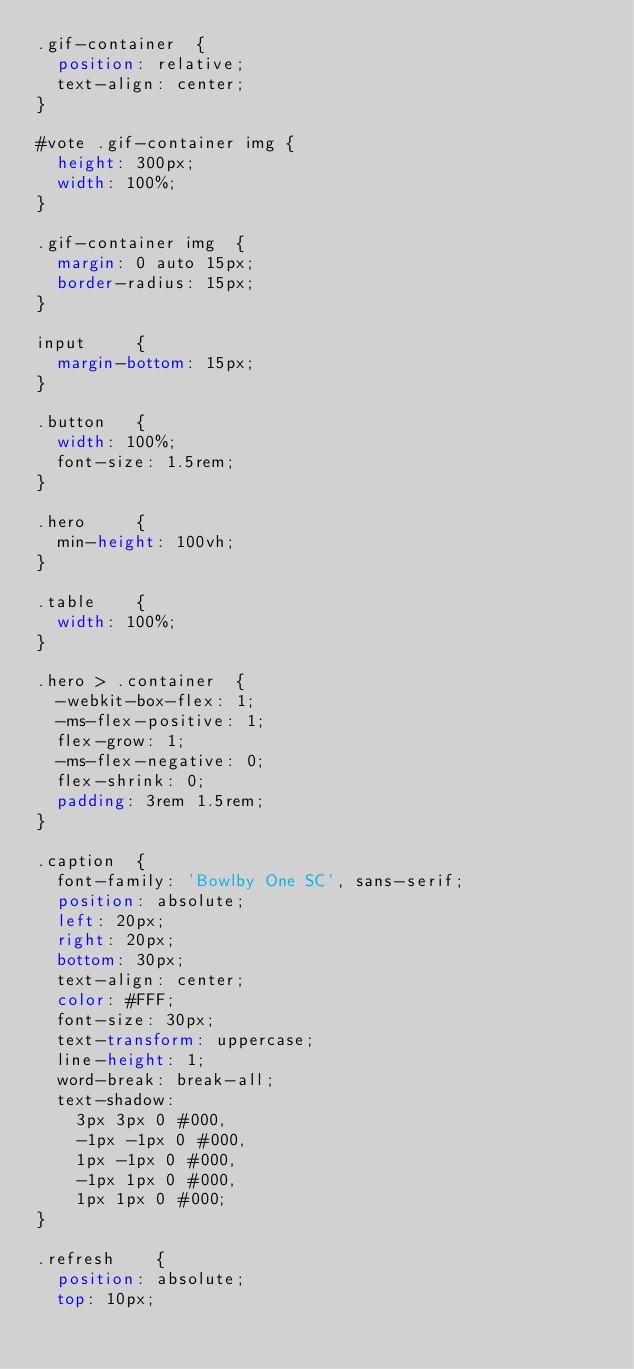Convert code to text. <code><loc_0><loc_0><loc_500><loc_500><_CSS_>.gif-container  {
  position: relative;
  text-align: center;
}

#vote .gif-container img {
  height: 300px;
  width: 100%;
}

.gif-container img  {
  margin: 0 auto 15px;
  border-radius: 15px;
}

input     {
  margin-bottom: 15px;
}

.button   {
  width: 100%;
  font-size: 1.5rem;
}

.hero     {
  min-height: 100vh;
}

.table    {
  width: 100%;
}

.hero > .container  {
  -webkit-box-flex: 1;
  -ms-flex-positive: 1;
  flex-grow: 1;
  -ms-flex-negative: 0;
  flex-shrink: 0;
  padding: 3rem 1.5rem;
}

.caption  {
  font-family: 'Bowlby One SC', sans-serif;
  position: absolute;
  left: 20px;
  right: 20px;
  bottom: 30px;
  text-align: center;
  color: #FFF;
  font-size: 30px;
  text-transform: uppercase;
  line-height: 1;
  word-break: break-all;
  text-shadow:
    3px 3px 0 #000,
    -1px -1px 0 #000,  
    1px -1px 0 #000,
    -1px 1px 0 #000,
    1px 1px 0 #000;
}

.refresh    {
  position: absolute;
  top: 10px;</code> 